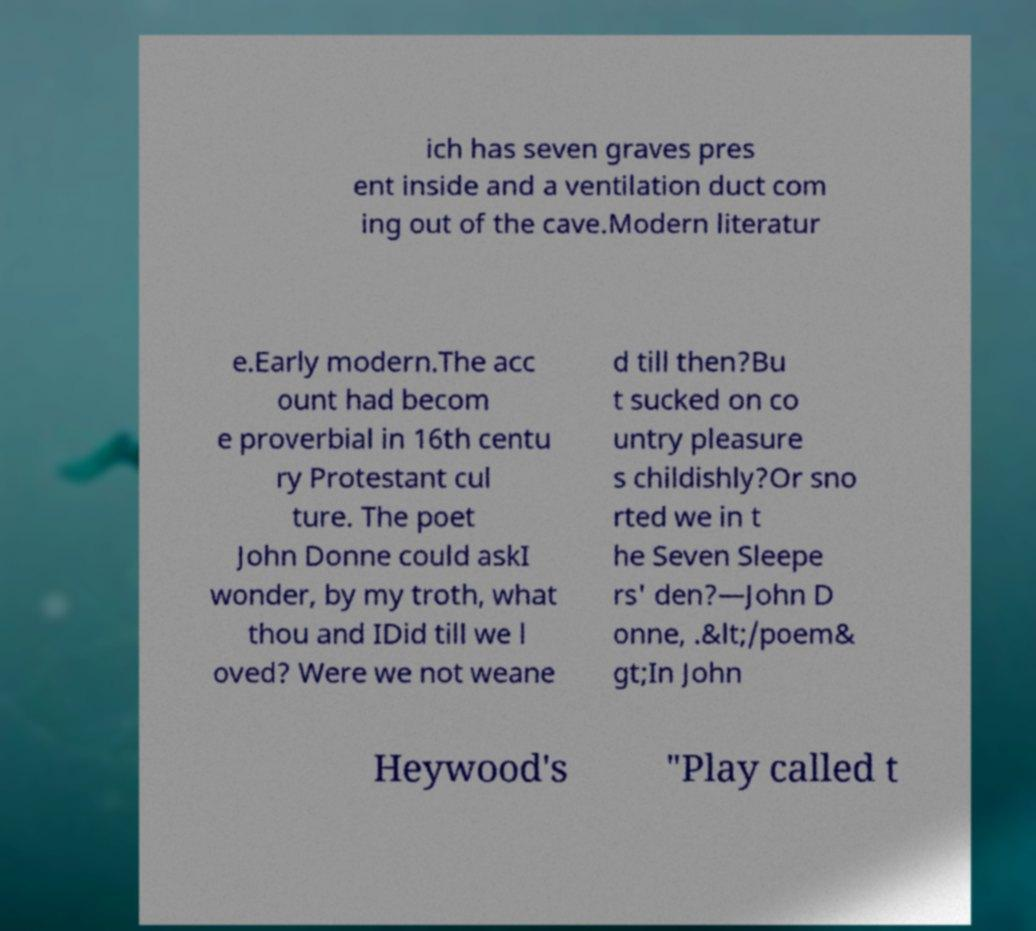Can you read and provide the text displayed in the image?This photo seems to have some interesting text. Can you extract and type it out for me? ich has seven graves pres ent inside and a ventilation duct com ing out of the cave.Modern literatur e.Early modern.The acc ount had becom e proverbial in 16th centu ry Protestant cul ture. The poet John Donne could askI wonder, by my troth, what thou and IDid till we l oved? Were we not weane d till then?Bu t sucked on co untry pleasure s childishly?Or sno rted we in t he Seven Sleepe rs' den?—John D onne, .&lt;/poem& gt;In John Heywood's "Play called t 